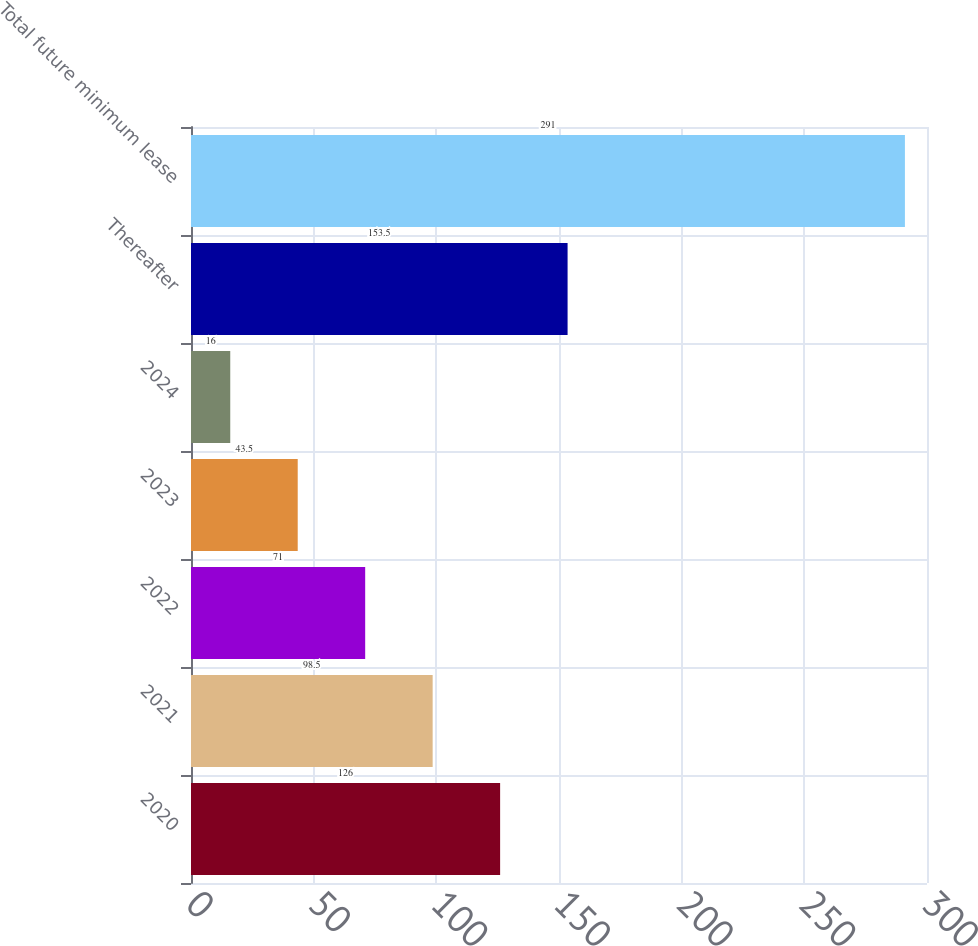Convert chart. <chart><loc_0><loc_0><loc_500><loc_500><bar_chart><fcel>2020<fcel>2021<fcel>2022<fcel>2023<fcel>2024<fcel>Thereafter<fcel>Total future minimum lease<nl><fcel>126<fcel>98.5<fcel>71<fcel>43.5<fcel>16<fcel>153.5<fcel>291<nl></chart> 